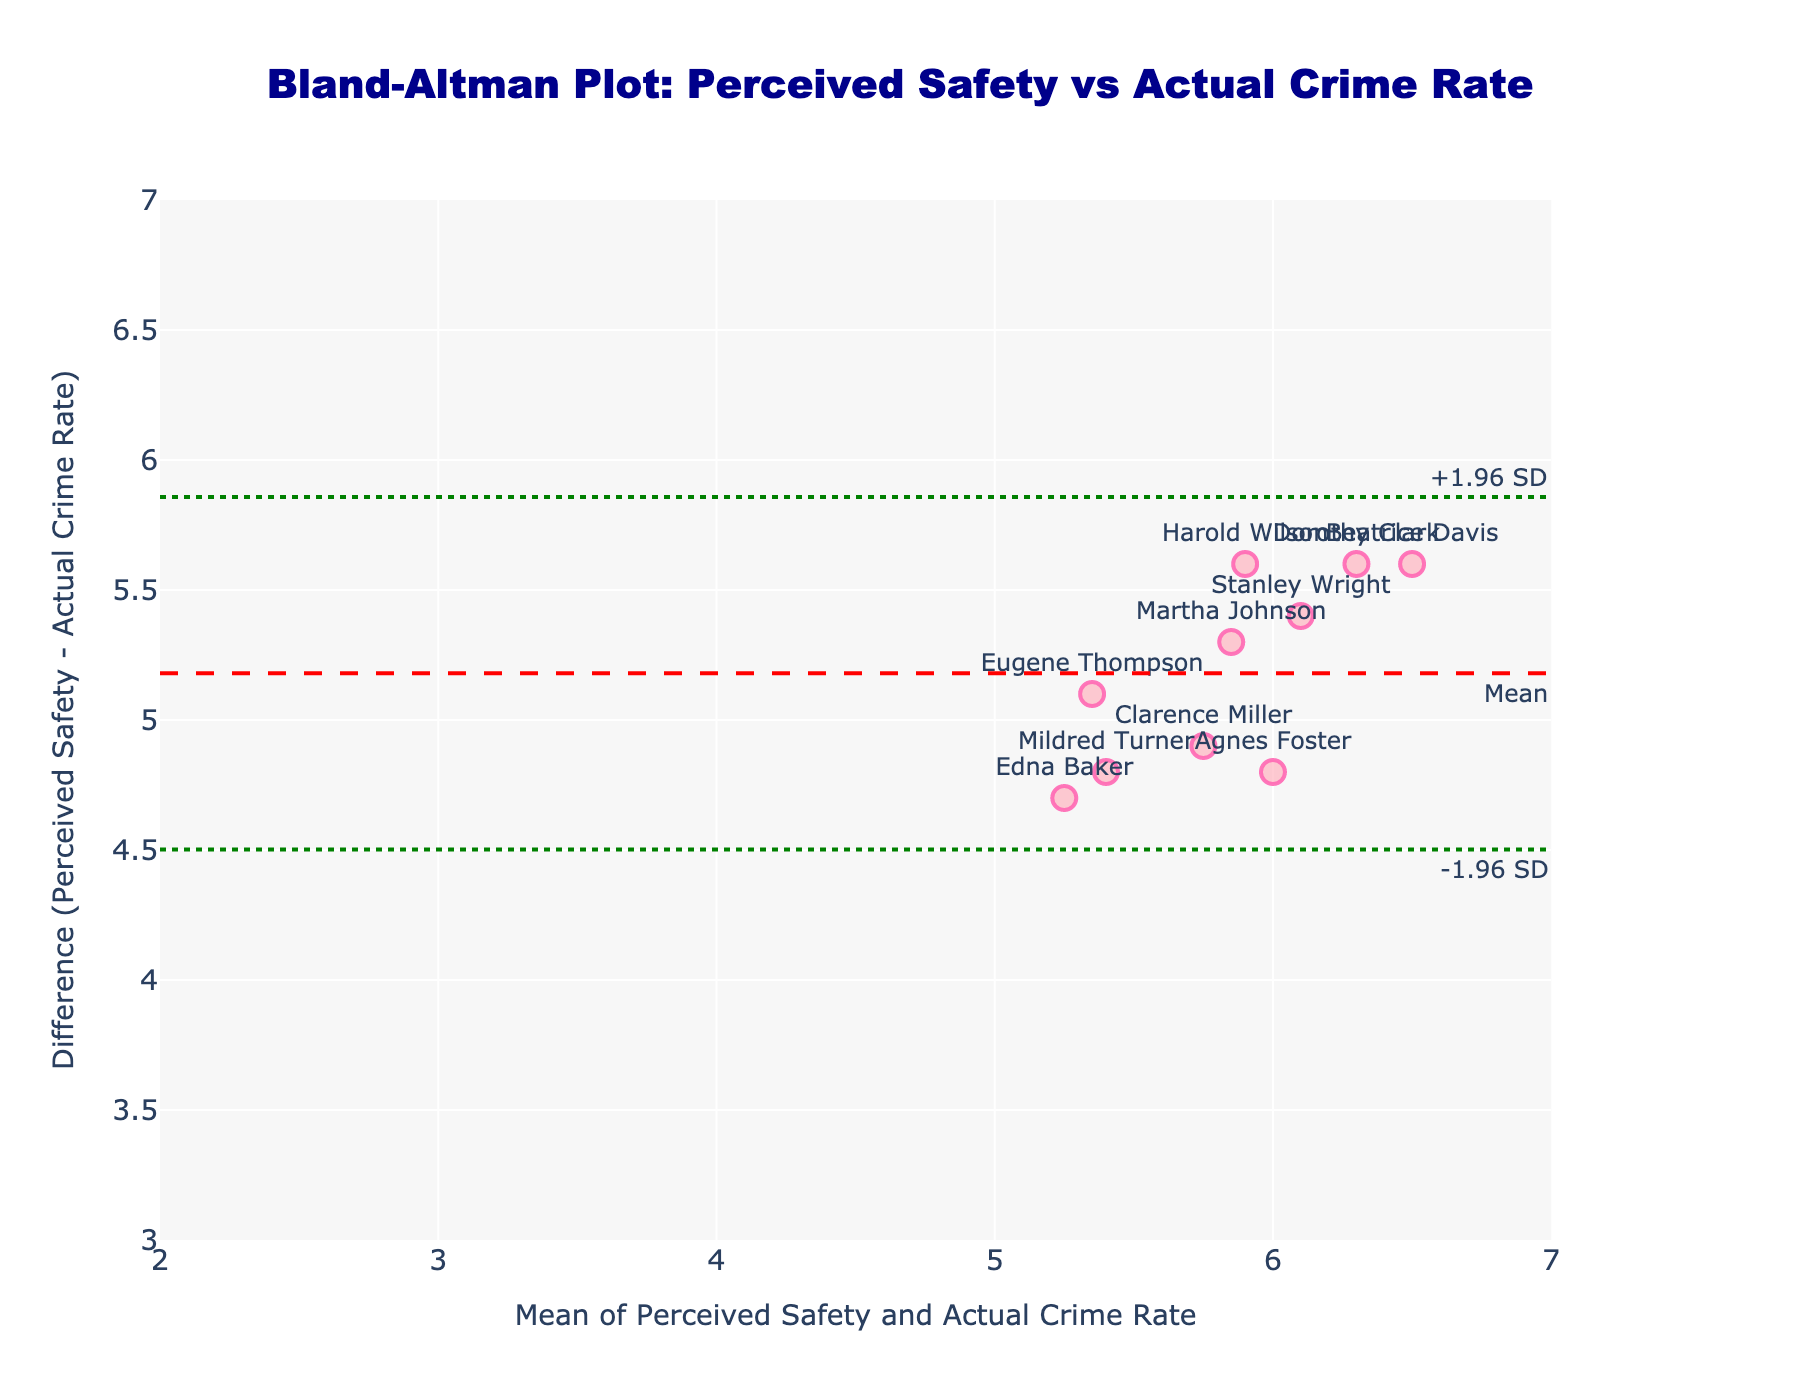What's the title of the plot? The title of the plot is displayed prominently at the top center of the figure. It usually describes what the plot is showing.
Answer: Bland-Altman Plot: Perceived Safety vs Actual Crime Rate What is represented on the x-axis? The label on the x-axis shows what is being measured. In this case, it represents the mean of Perceived Safety and Actual Crime Rate.
Answer: Mean of Perceived Safety and Actual Crime Rate What is the y-axis title? The y-axis title is displayed on the vertical axis and shows what is plotted on that axis. Here it represents the difference between Perceived Safety and Actual Crime Rate.
Answer: Difference (Perceived Safety - Actual Crime Rate) How many residents' data points are displayed in the plot? To find the number of residents' data points, look for the number of markers scattered on the plot. Each marker represents a different resident.
Answer: 10 What color are the markers for the data points? The markers' color can be determined by looking at the data points in the plot. They are mostly a shade of pink with some light effects around the edge.
Answer: Pink Where does the mean difference line lie on the y-axis? The mean difference line is indicated by a horizontal dashed red line on the plot. Look at its y-coordinate position.
Answer: Around 5.1 What are the values of the upper and lower limits of agreement? The values of the upper and lower limits of agreement are shown by dotted green lines. The annotation text or horizontal lines themselves help locate their exact y-coordinates.
Answer: Upper: ~6.4, Lower: ~3.8 Which resident has the highest positive difference between Perceived Safety and Actual Crime Rate? Find the marker with the highest y-value (indicating the largest positive difference), and identify the resident's name from the text label associated with that marker.
Answer: Dorothy Clark How many residents perceive safety higher than the actual crime rate? Count the number of data points that are above the y-axis line where the difference is zero. Each of these points represents a resident who perceives higher safety than the actual crime rate.
Answer: 10 Which residents have the closest perception of safety levels to the actual crime rate (i.e., smallest difference)? Look for markers closest to the horizontal y=0 line, indicating the smallest difference between perceived and actual values. Identify the residents from the text label.
Answer: Eugene Thompson, Mildred Turner 